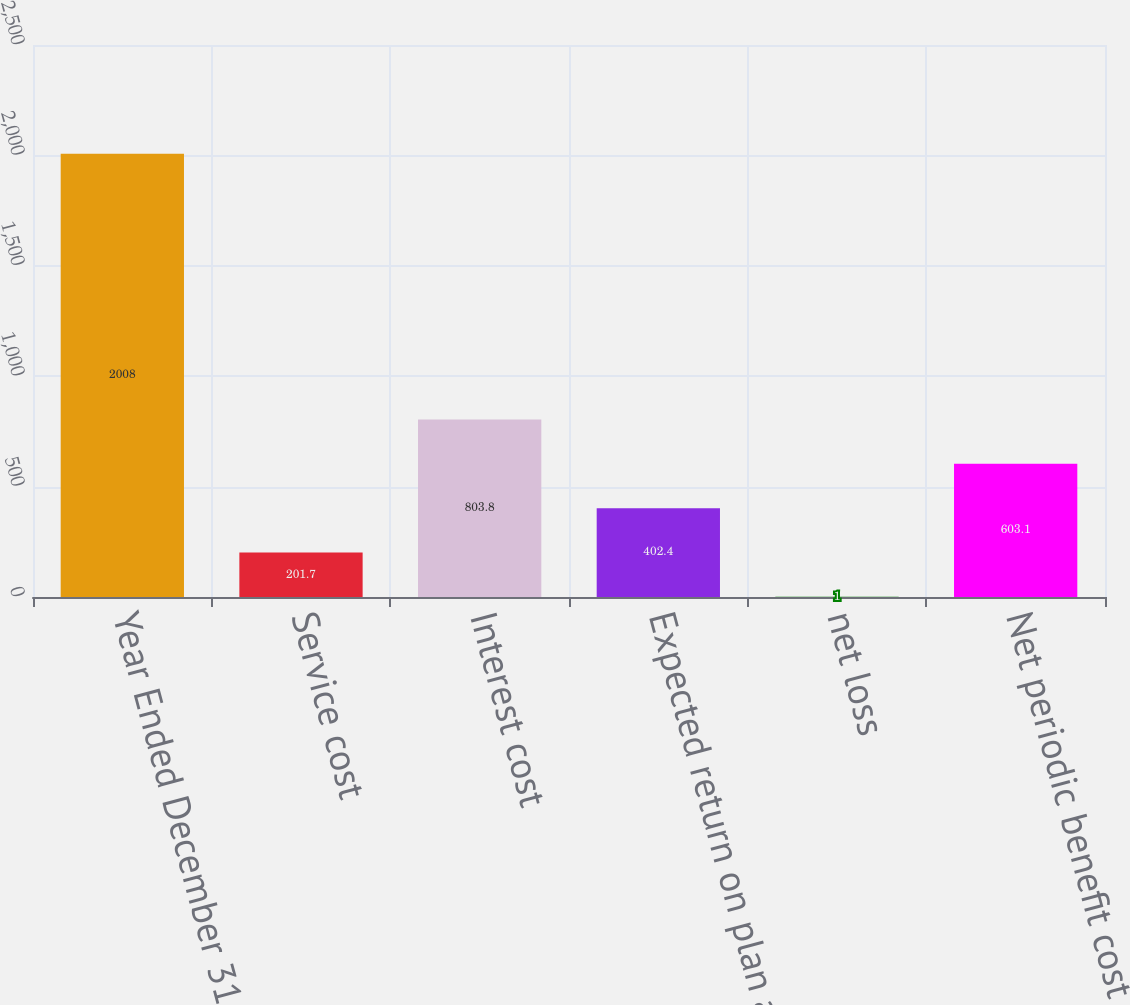<chart> <loc_0><loc_0><loc_500><loc_500><bar_chart><fcel>Year Ended December 31<fcel>Service cost<fcel>Interest cost<fcel>Expected return on plan assets<fcel>net loss<fcel>Net periodic benefit cost<nl><fcel>2008<fcel>201.7<fcel>803.8<fcel>402.4<fcel>1<fcel>603.1<nl></chart> 